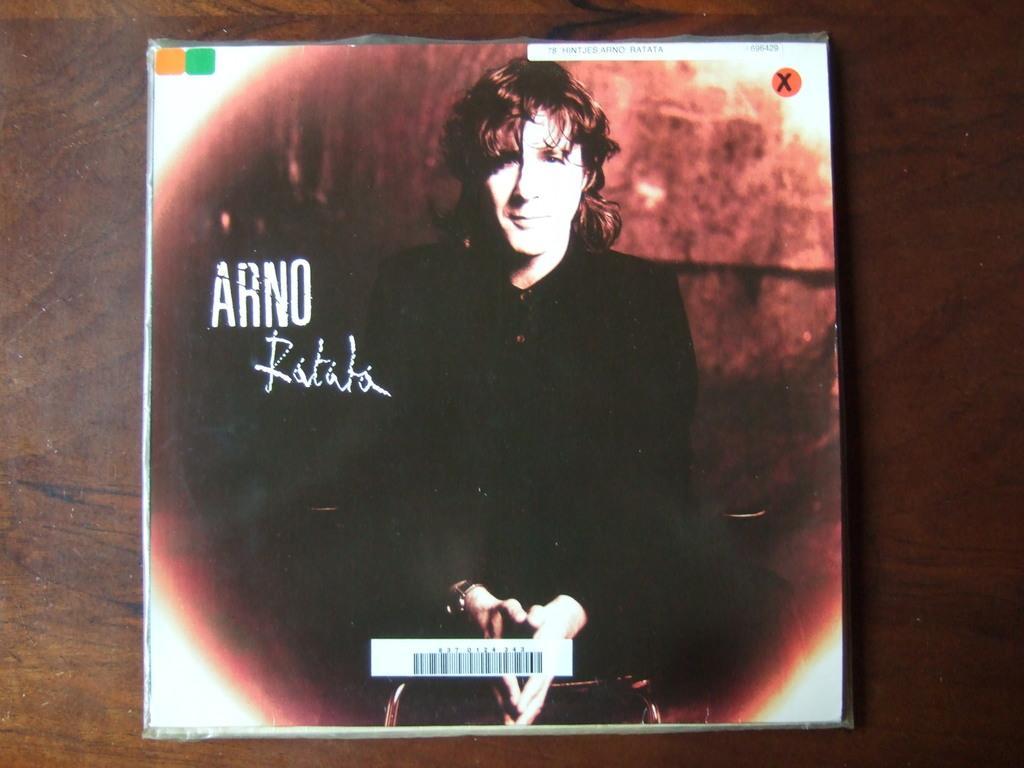Please provide a concise description of this image. In this picture I can see the compact disc cover. I can see the picture of a person on it. 